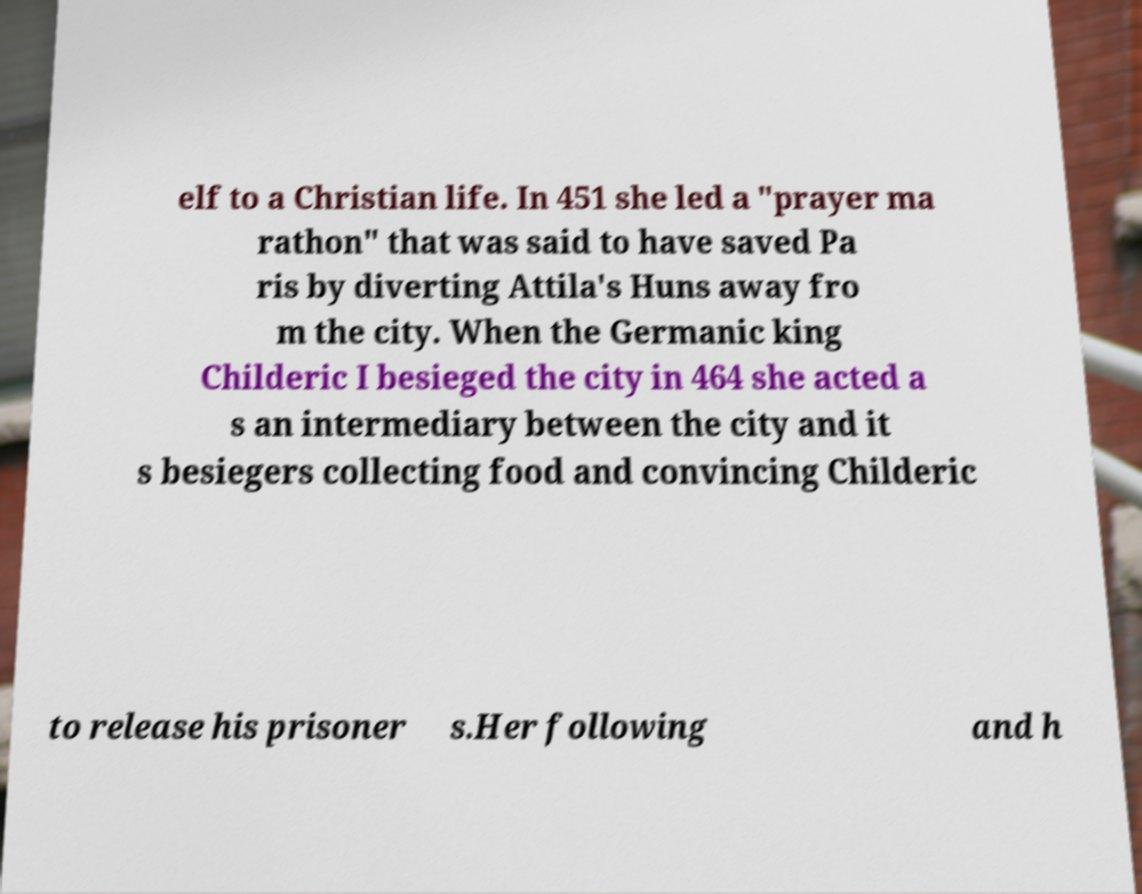Could you extract and type out the text from this image? elf to a Christian life. In 451 she led a "prayer ma rathon" that was said to have saved Pa ris by diverting Attila's Huns away fro m the city. When the Germanic king Childeric I besieged the city in 464 she acted a s an intermediary between the city and it s besiegers collecting food and convincing Childeric to release his prisoner s.Her following and h 